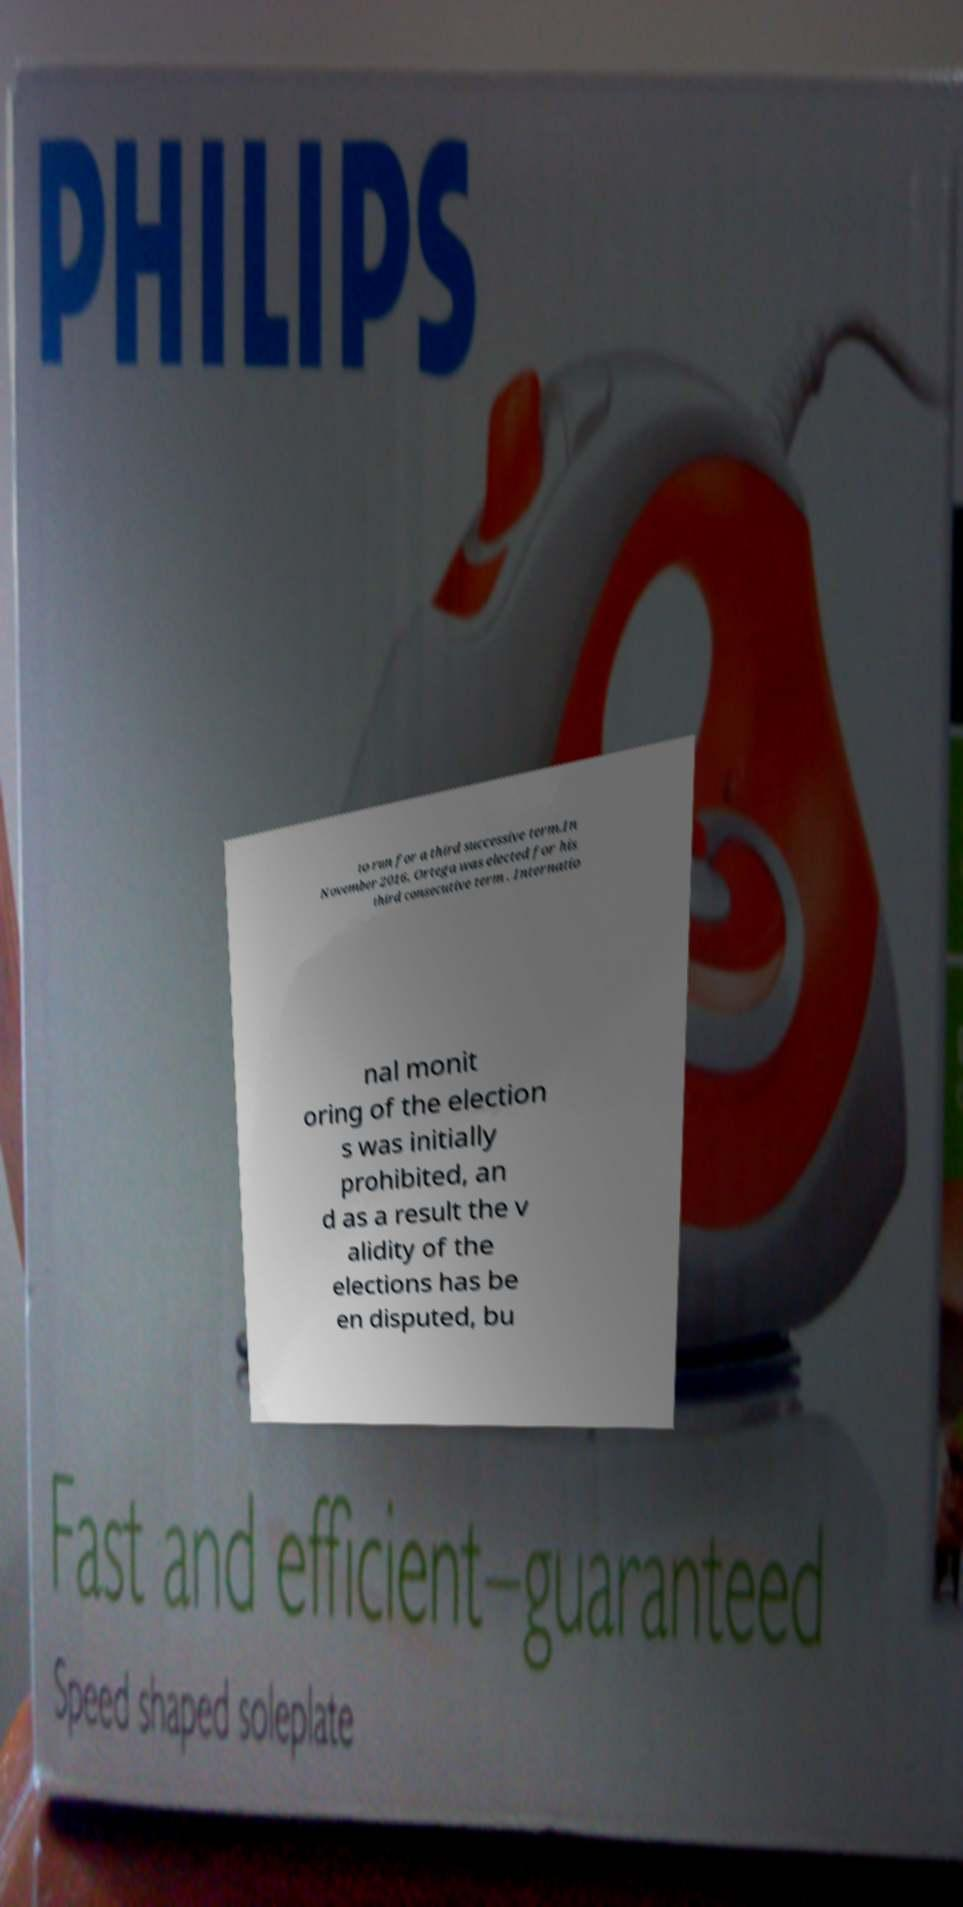Can you accurately transcribe the text from the provided image for me? to run for a third successive term.In November 2016, Ortega was elected for his third consecutive term . Internatio nal monit oring of the election s was initially prohibited, an d as a result the v alidity of the elections has be en disputed, bu 